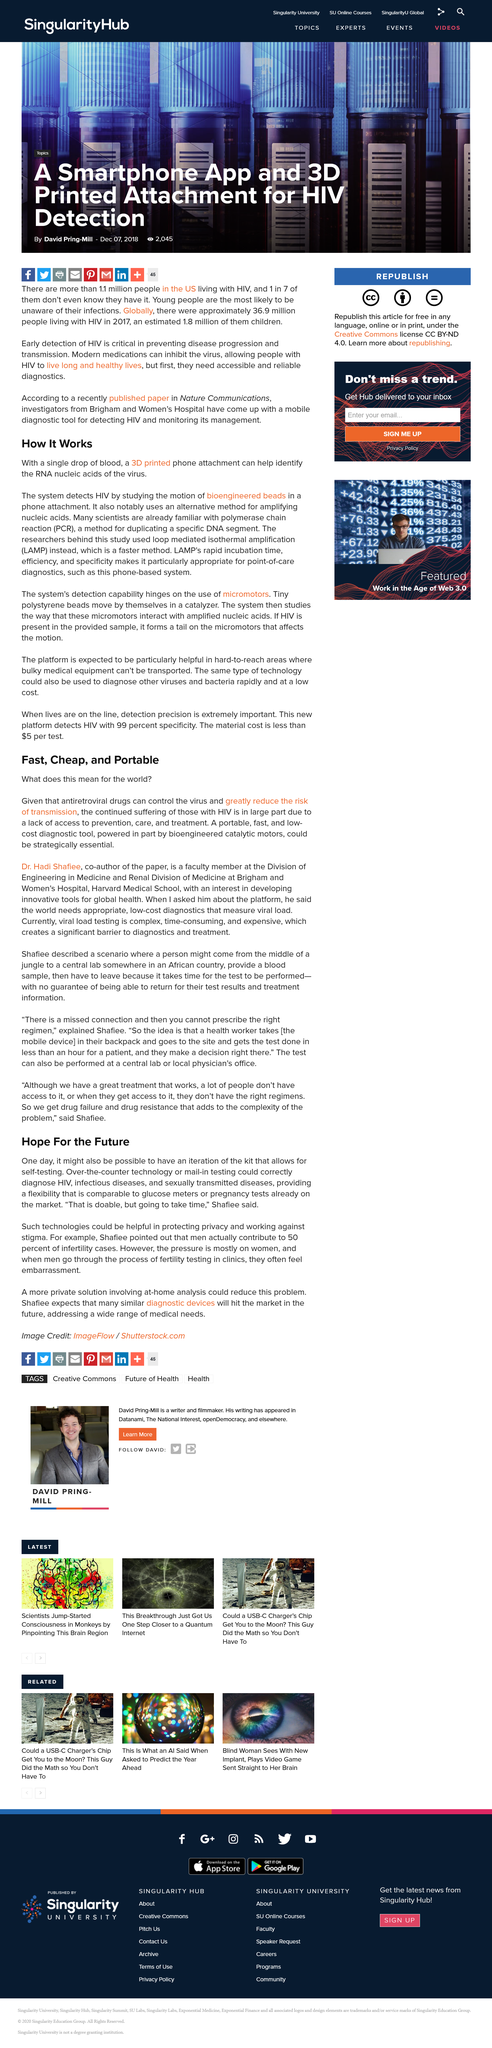Outline some significant characteristics in this image. It is estimated that approximately 50% of infertility cases are caused by male factors. Antiretroviral drugs are effective in controlling the virus. The main causes of continued suffering for those with HIV are due in large part to a lack of access to prevention, care, and treatment. Over-the-counter technology and mail-in testing are technologies that can help protect privacy and work against stigma. Over-the-counter technology has the potential to test for a variety of diseases, including HIV, infectious diseases, and sexually transmitted diseases. 